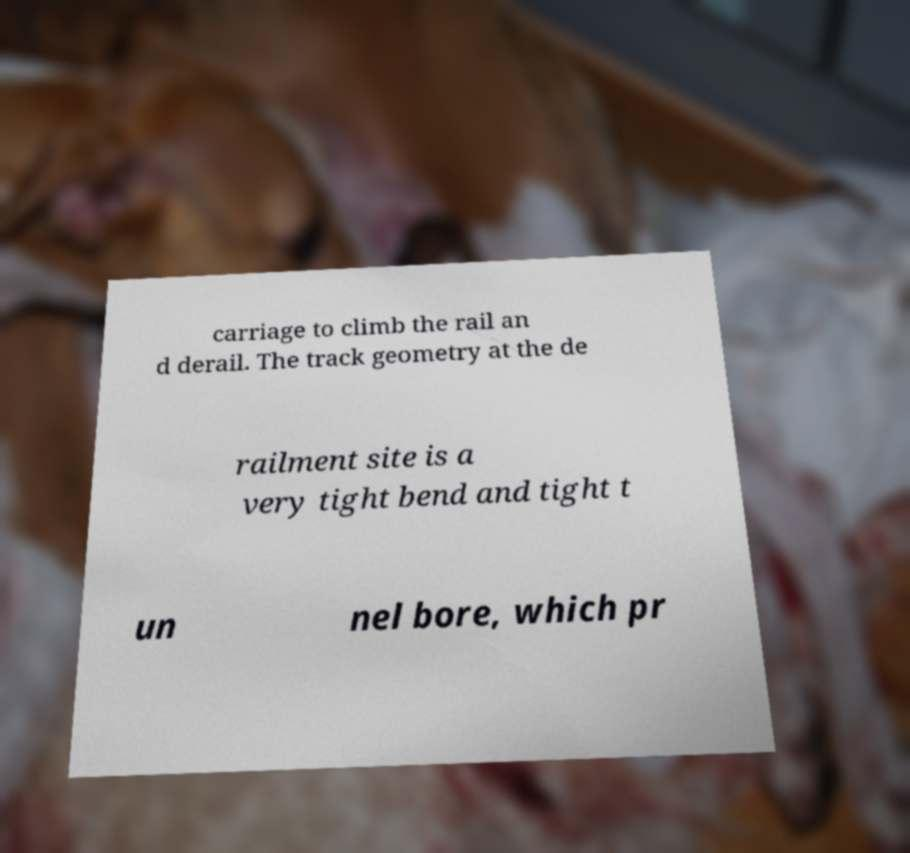There's text embedded in this image that I need extracted. Can you transcribe it verbatim? carriage to climb the rail an d derail. The track geometry at the de railment site is a very tight bend and tight t un nel bore, which pr 